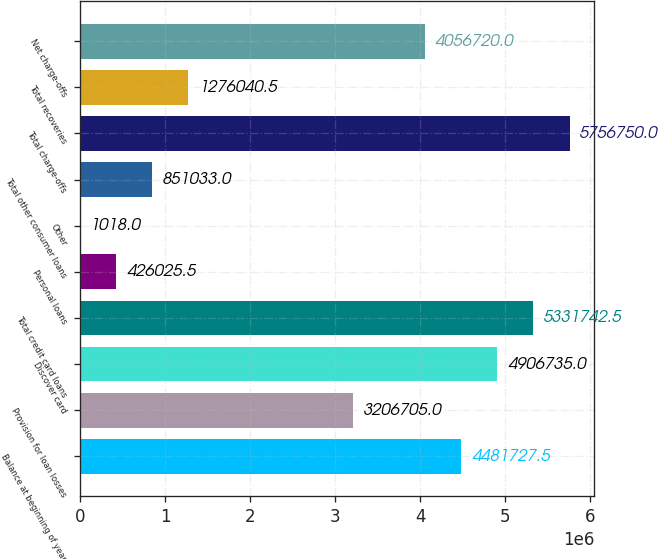Convert chart. <chart><loc_0><loc_0><loc_500><loc_500><bar_chart><fcel>Balance at beginning of year<fcel>Provision for loan losses<fcel>Discover card<fcel>Total credit card loans<fcel>Personal loans<fcel>Other<fcel>Total other consumer loans<fcel>Total charge-offs<fcel>Total recoveries<fcel>Net charge-offs<nl><fcel>4.48173e+06<fcel>3.2067e+06<fcel>4.90674e+06<fcel>5.33174e+06<fcel>426026<fcel>1018<fcel>851033<fcel>5.75675e+06<fcel>1.27604e+06<fcel>4.05672e+06<nl></chart> 